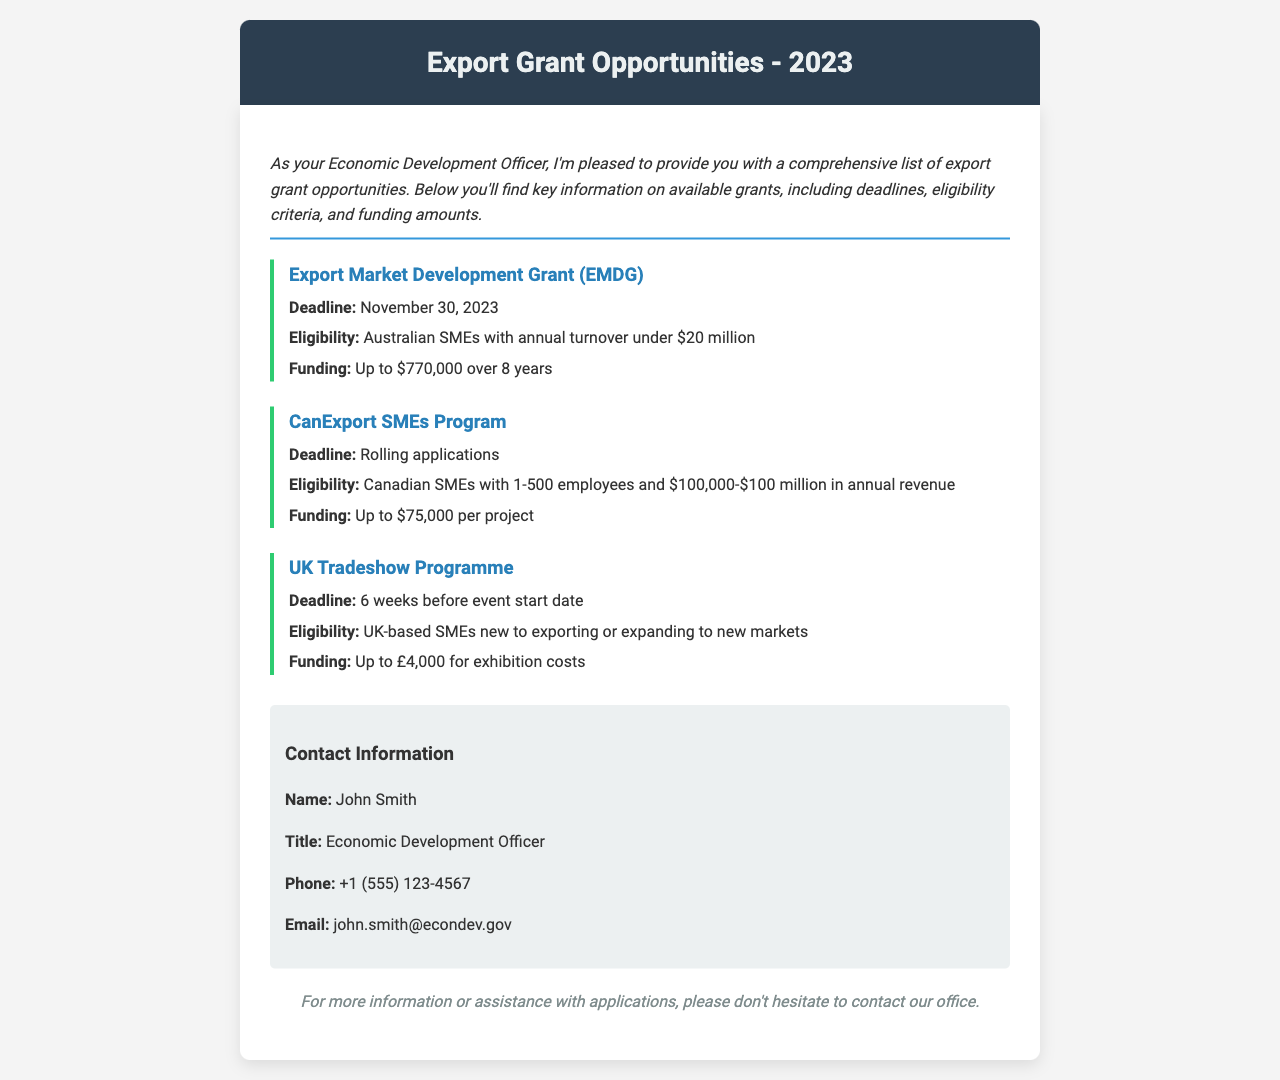what is the deadline for the Export Market Development Grant? The deadline for this grant is mentioned directly in the document.
Answer: November 30, 2023 who is eligible for the CanExport SMEs Program? Eligibility criteria for this program is laid out in the document, specifying the type of businesses that qualify.
Answer: Canadian SMEs with 1-500 employees and $100,000-$100 million in annual revenue how much funding can one get through the UK Tradeshow Programme? The funding amount is explicitly stated in the document for this grant opportunity.
Answer: Up to £4,000 for exhibition costs what is the title of John Smith? The document includes the contact information section where the title is provided.
Answer: Economic Development Officer what is the maximum funding amount for the Export Market Development Grant? The document specifies the maximum funding available for this particular grant.
Answer: Up to $770,000 over 8 years what is the contact email for John Smith? The document provides the email address of John Smith in the contact information section.
Answer: john.smith@econdev.gov when can applications be submitted for the CanExport SMEs Program? The document indicates that applications can be submitted at any time, which is important for understanding the program's accessibility.
Answer: Rolling applications who can apply for the UK Tradeshow Programme? This information is crucial to know who can benefit from the grant, as stated in the document.
Answer: UK-based SMEs new to exporting or expanding to new markets 